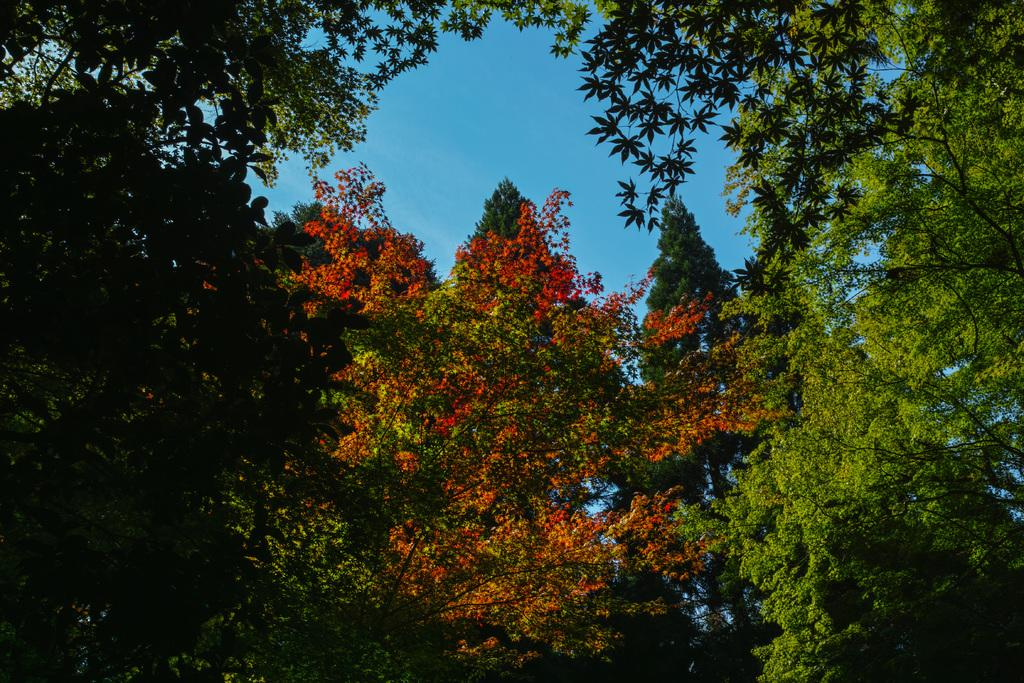What type of vegetation can be seen in the image? There are trees in the image. What part of the natural environment is visible in the image? The sky is visible in the background of the image. How many apples can be seen hanging from the trees in the image? There are no apples present in the image; only trees and the sky are visible. Can you describe how the trees are stretching towards the sky in the image? The trees are not depicted as stretching towards the sky in the image; they are simply standing in their natural positions. 